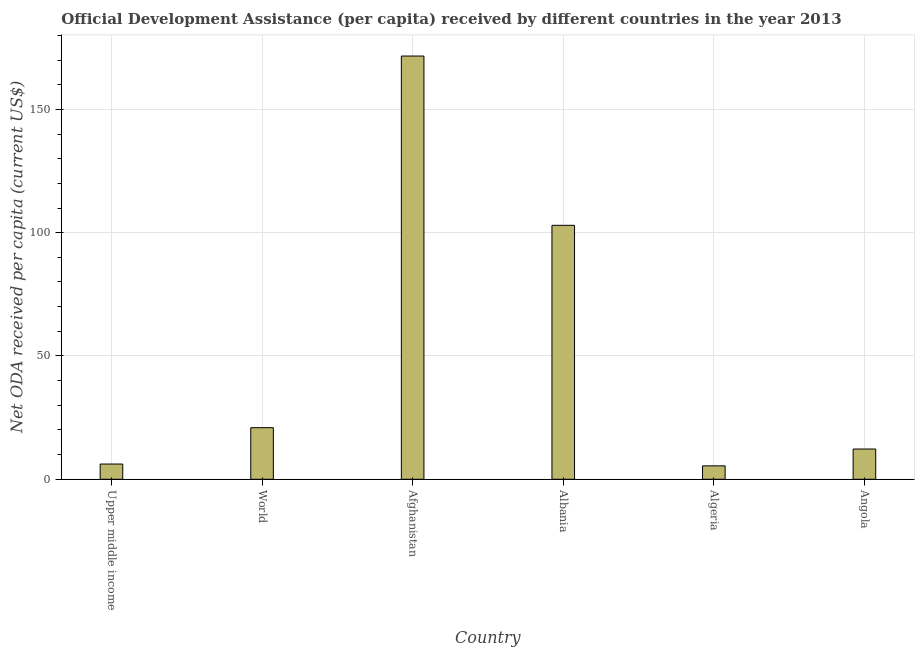What is the title of the graph?
Keep it short and to the point. Official Development Assistance (per capita) received by different countries in the year 2013. What is the label or title of the Y-axis?
Offer a very short reply. Net ODA received per capita (current US$). What is the net oda received per capita in Upper middle income?
Your response must be concise. 6.18. Across all countries, what is the maximum net oda received per capita?
Keep it short and to the point. 171.63. Across all countries, what is the minimum net oda received per capita?
Your answer should be compact. 5.45. In which country was the net oda received per capita maximum?
Your response must be concise. Afghanistan. In which country was the net oda received per capita minimum?
Your answer should be compact. Algeria. What is the sum of the net oda received per capita?
Keep it short and to the point. 319.42. What is the difference between the net oda received per capita in Afghanistan and Angola?
Your response must be concise. 159.36. What is the average net oda received per capita per country?
Your answer should be compact. 53.24. What is the median net oda received per capita?
Your answer should be very brief. 16.59. In how many countries, is the net oda received per capita greater than 30 US$?
Your answer should be very brief. 2. What is the ratio of the net oda received per capita in Albania to that in World?
Offer a terse response. 4.92. Is the net oda received per capita in Afghanistan less than that in World?
Offer a terse response. No. Is the difference between the net oda received per capita in Upper middle income and World greater than the difference between any two countries?
Your answer should be very brief. No. What is the difference between the highest and the second highest net oda received per capita?
Your answer should be very brief. 68.64. Is the sum of the net oda received per capita in Angola and Upper middle income greater than the maximum net oda received per capita across all countries?
Your answer should be compact. No. What is the difference between the highest and the lowest net oda received per capita?
Provide a succinct answer. 166.18. In how many countries, is the net oda received per capita greater than the average net oda received per capita taken over all countries?
Your response must be concise. 2. How many bars are there?
Offer a very short reply. 6. What is the Net ODA received per capita (current US$) of Upper middle income?
Offer a terse response. 6.18. What is the Net ODA received per capita (current US$) of World?
Offer a very short reply. 20.92. What is the Net ODA received per capita (current US$) in Afghanistan?
Offer a terse response. 171.63. What is the Net ODA received per capita (current US$) in Albania?
Give a very brief answer. 102.98. What is the Net ODA received per capita (current US$) in Algeria?
Offer a very short reply. 5.45. What is the Net ODA received per capita (current US$) in Angola?
Your response must be concise. 12.27. What is the difference between the Net ODA received per capita (current US$) in Upper middle income and World?
Ensure brevity in your answer.  -14.74. What is the difference between the Net ODA received per capita (current US$) in Upper middle income and Afghanistan?
Make the answer very short. -165.45. What is the difference between the Net ODA received per capita (current US$) in Upper middle income and Albania?
Provide a succinct answer. -96.8. What is the difference between the Net ODA received per capita (current US$) in Upper middle income and Algeria?
Ensure brevity in your answer.  0.73. What is the difference between the Net ODA received per capita (current US$) in Upper middle income and Angola?
Make the answer very short. -6.09. What is the difference between the Net ODA received per capita (current US$) in World and Afghanistan?
Ensure brevity in your answer.  -150.71. What is the difference between the Net ODA received per capita (current US$) in World and Albania?
Your response must be concise. -82.06. What is the difference between the Net ODA received per capita (current US$) in World and Algeria?
Offer a very short reply. 15.47. What is the difference between the Net ODA received per capita (current US$) in World and Angola?
Ensure brevity in your answer.  8.65. What is the difference between the Net ODA received per capita (current US$) in Afghanistan and Albania?
Make the answer very short. 68.64. What is the difference between the Net ODA received per capita (current US$) in Afghanistan and Algeria?
Provide a short and direct response. 166.18. What is the difference between the Net ODA received per capita (current US$) in Afghanistan and Angola?
Keep it short and to the point. 159.36. What is the difference between the Net ODA received per capita (current US$) in Albania and Algeria?
Keep it short and to the point. 97.54. What is the difference between the Net ODA received per capita (current US$) in Albania and Angola?
Make the answer very short. 90.72. What is the difference between the Net ODA received per capita (current US$) in Algeria and Angola?
Give a very brief answer. -6.82. What is the ratio of the Net ODA received per capita (current US$) in Upper middle income to that in World?
Offer a very short reply. 0.29. What is the ratio of the Net ODA received per capita (current US$) in Upper middle income to that in Afghanistan?
Keep it short and to the point. 0.04. What is the ratio of the Net ODA received per capita (current US$) in Upper middle income to that in Albania?
Provide a succinct answer. 0.06. What is the ratio of the Net ODA received per capita (current US$) in Upper middle income to that in Algeria?
Make the answer very short. 1.14. What is the ratio of the Net ODA received per capita (current US$) in Upper middle income to that in Angola?
Provide a succinct answer. 0.5. What is the ratio of the Net ODA received per capita (current US$) in World to that in Afghanistan?
Your response must be concise. 0.12. What is the ratio of the Net ODA received per capita (current US$) in World to that in Albania?
Your response must be concise. 0.2. What is the ratio of the Net ODA received per capita (current US$) in World to that in Algeria?
Ensure brevity in your answer.  3.84. What is the ratio of the Net ODA received per capita (current US$) in World to that in Angola?
Provide a succinct answer. 1.71. What is the ratio of the Net ODA received per capita (current US$) in Afghanistan to that in Albania?
Offer a terse response. 1.67. What is the ratio of the Net ODA received per capita (current US$) in Afghanistan to that in Algeria?
Give a very brief answer. 31.52. What is the ratio of the Net ODA received per capita (current US$) in Afghanistan to that in Angola?
Your answer should be compact. 13.99. What is the ratio of the Net ODA received per capita (current US$) in Albania to that in Algeria?
Offer a terse response. 18.91. What is the ratio of the Net ODA received per capita (current US$) in Albania to that in Angola?
Your response must be concise. 8.4. What is the ratio of the Net ODA received per capita (current US$) in Algeria to that in Angola?
Provide a succinct answer. 0.44. 